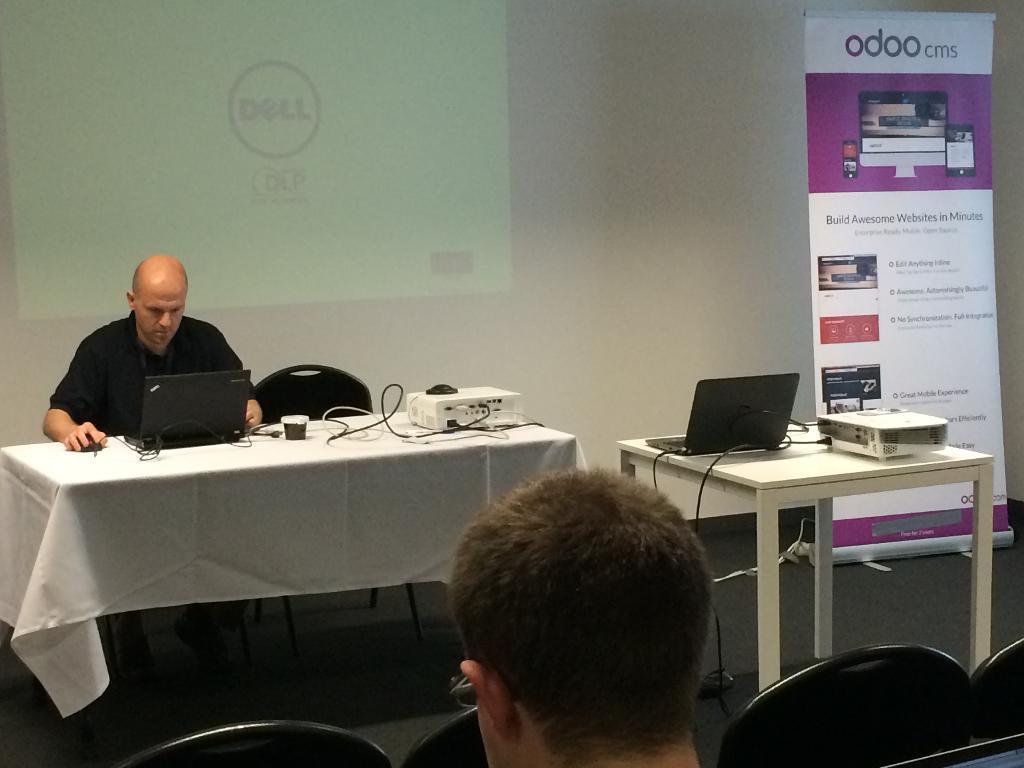Can you describe this image briefly? In this there is picture of man sitting over here with his laptop and is a project over here there some other empty chairs over here and man sitting over here 